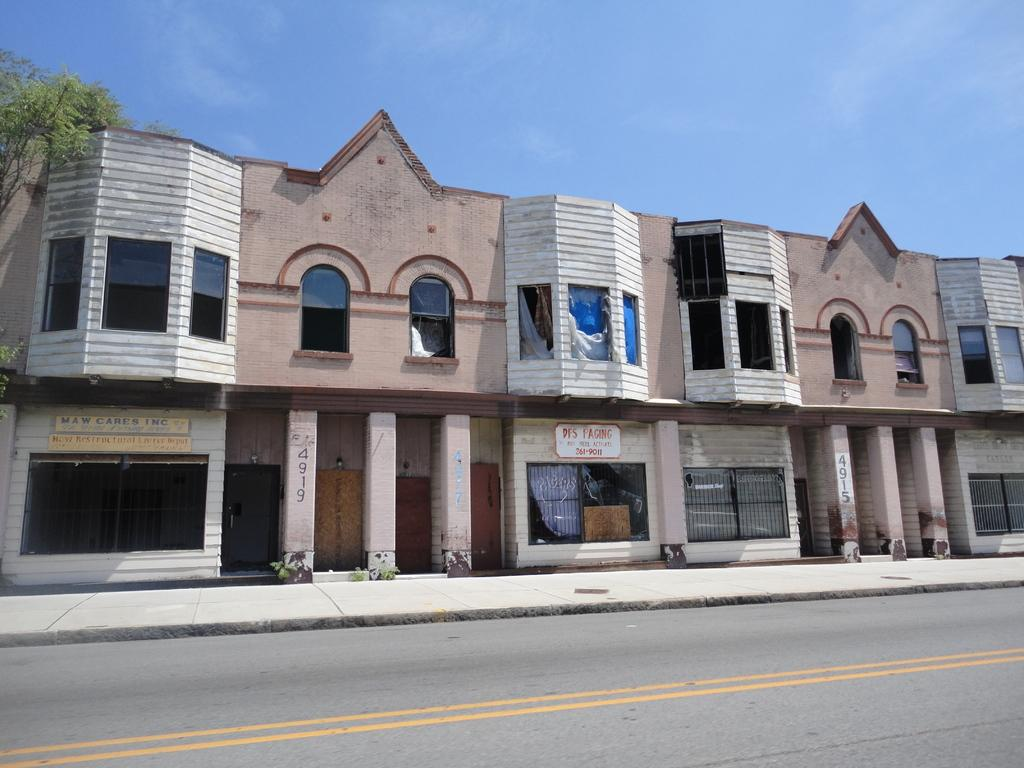What type of structures can be seen in the image? There are buildings in the image. What is another feature visible in the image besides the buildings? There is a road visible in the image. How would you describe the weather based on the image? The sky is cloudy in the image. What type of vegetation is present in the image? There is a tree in the image. What type of pets can be seen in the image? There are no pets present in the image. What type of coil is used to support the buildings in the image? There is no coil present in the image, and the buildings are supported by their own structures. What type of religious symbol can be seen in the image? There is no religious symbol present in the image. 